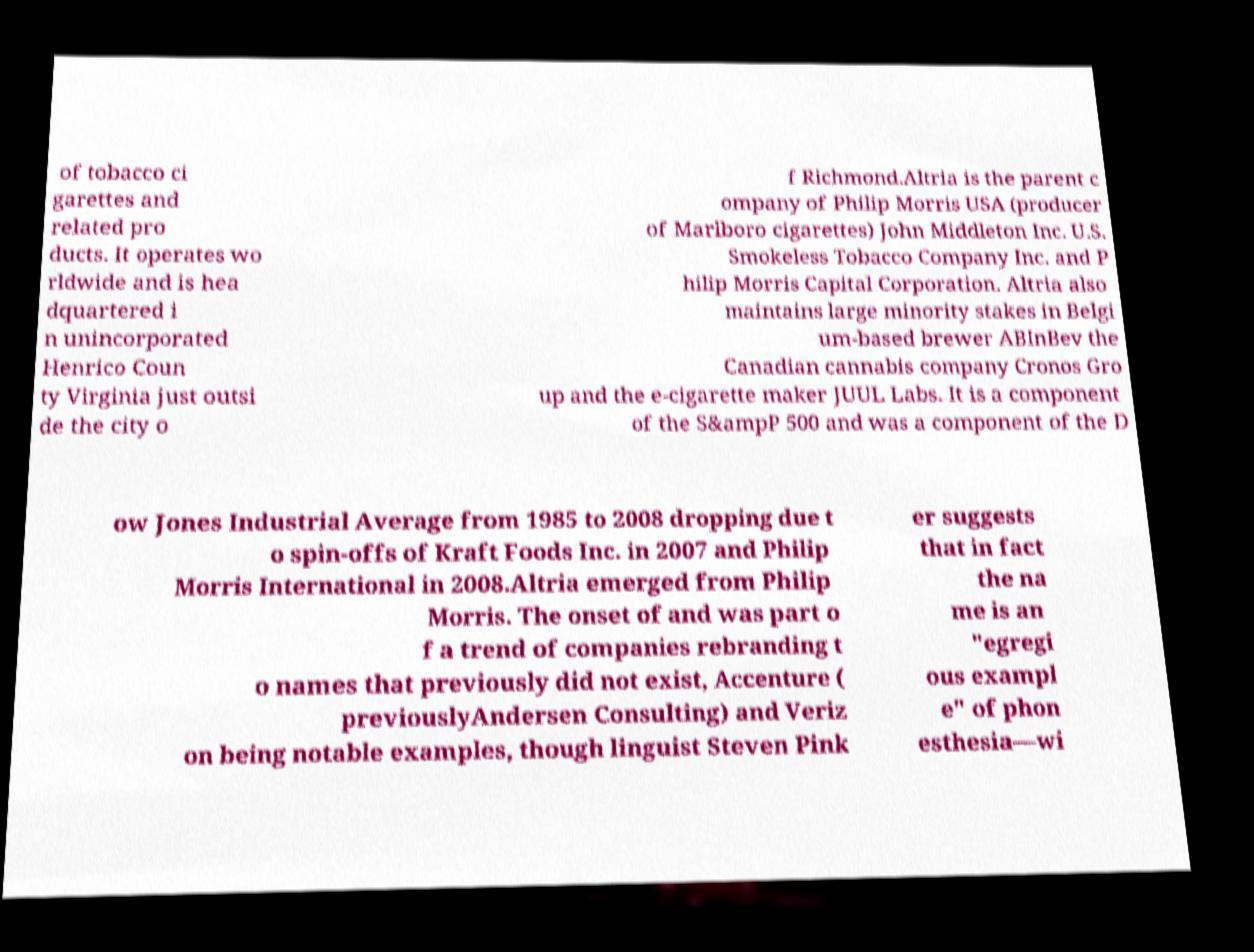Could you assist in decoding the text presented in this image and type it out clearly? of tobacco ci garettes and related pro ducts. It operates wo rldwide and is hea dquartered i n unincorporated Henrico Coun ty Virginia just outsi de the city o f Richmond.Altria is the parent c ompany of Philip Morris USA (producer of Marlboro cigarettes) John Middleton Inc. U.S. Smokeless Tobacco Company Inc. and P hilip Morris Capital Corporation. Altria also maintains large minority stakes in Belgi um-based brewer ABInBev the Canadian cannabis company Cronos Gro up and the e-cigarette maker JUUL Labs. It is a component of the S&ampP 500 and was a component of the D ow Jones Industrial Average from 1985 to 2008 dropping due t o spin-offs of Kraft Foods Inc. in 2007 and Philip Morris International in 2008.Altria emerged from Philip Morris. The onset of and was part o f a trend of companies rebranding t o names that previously did not exist, Accenture ( previouslyAndersen Consulting) and Veriz on being notable examples, though linguist Steven Pink er suggests that in fact the na me is an "egregi ous exampl e" of phon esthesia—wi 